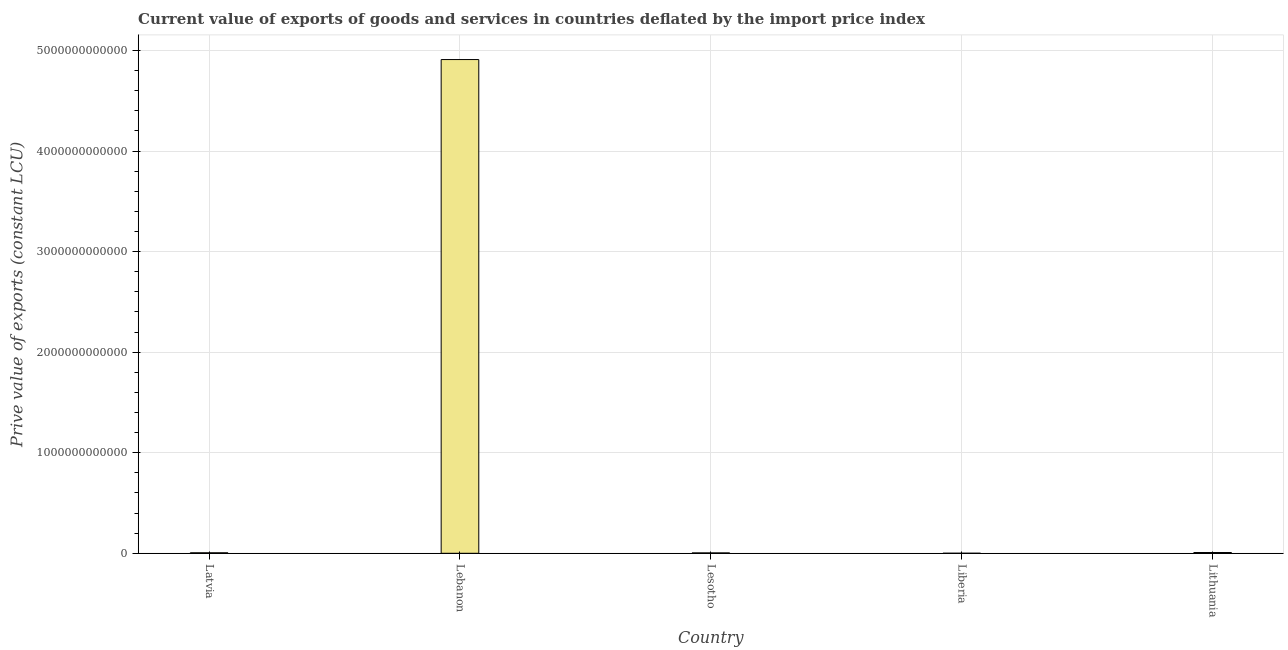Does the graph contain any zero values?
Your answer should be compact. No. What is the title of the graph?
Offer a very short reply. Current value of exports of goods and services in countries deflated by the import price index. What is the label or title of the X-axis?
Ensure brevity in your answer.  Country. What is the label or title of the Y-axis?
Ensure brevity in your answer.  Prive value of exports (constant LCU). What is the price value of exports in Latvia?
Ensure brevity in your answer.  4.90e+09. Across all countries, what is the maximum price value of exports?
Offer a very short reply. 4.91e+12. Across all countries, what is the minimum price value of exports?
Ensure brevity in your answer.  1.85e+08. In which country was the price value of exports maximum?
Your answer should be compact. Lebanon. In which country was the price value of exports minimum?
Your response must be concise. Liberia. What is the sum of the price value of exports?
Ensure brevity in your answer.  4.93e+12. What is the difference between the price value of exports in Lesotho and Lithuania?
Provide a short and direct response. -3.68e+09. What is the average price value of exports per country?
Offer a terse response. 9.85e+11. What is the median price value of exports?
Provide a succinct answer. 4.90e+09. What is the ratio of the price value of exports in Latvia to that in Lithuania?
Offer a terse response. 0.65. Is the price value of exports in Lebanon less than that in Lesotho?
Offer a terse response. No. What is the difference between the highest and the second highest price value of exports?
Provide a succinct answer. 4.90e+12. What is the difference between the highest and the lowest price value of exports?
Keep it short and to the point. 4.91e+12. Are all the bars in the graph horizontal?
Your answer should be compact. No. What is the difference between two consecutive major ticks on the Y-axis?
Provide a succinct answer. 1.00e+12. Are the values on the major ticks of Y-axis written in scientific E-notation?
Keep it short and to the point. No. What is the Prive value of exports (constant LCU) of Latvia?
Your answer should be very brief. 4.90e+09. What is the Prive value of exports (constant LCU) in Lebanon?
Give a very brief answer. 4.91e+12. What is the Prive value of exports (constant LCU) of Lesotho?
Keep it short and to the point. 3.86e+09. What is the Prive value of exports (constant LCU) in Liberia?
Make the answer very short. 1.85e+08. What is the Prive value of exports (constant LCU) in Lithuania?
Your response must be concise. 7.55e+09. What is the difference between the Prive value of exports (constant LCU) in Latvia and Lebanon?
Make the answer very short. -4.90e+12. What is the difference between the Prive value of exports (constant LCU) in Latvia and Lesotho?
Offer a terse response. 1.04e+09. What is the difference between the Prive value of exports (constant LCU) in Latvia and Liberia?
Offer a very short reply. 4.71e+09. What is the difference between the Prive value of exports (constant LCU) in Latvia and Lithuania?
Provide a short and direct response. -2.65e+09. What is the difference between the Prive value of exports (constant LCU) in Lebanon and Lesotho?
Provide a succinct answer. 4.91e+12. What is the difference between the Prive value of exports (constant LCU) in Lebanon and Liberia?
Your response must be concise. 4.91e+12. What is the difference between the Prive value of exports (constant LCU) in Lebanon and Lithuania?
Make the answer very short. 4.90e+12. What is the difference between the Prive value of exports (constant LCU) in Lesotho and Liberia?
Your answer should be very brief. 3.68e+09. What is the difference between the Prive value of exports (constant LCU) in Lesotho and Lithuania?
Provide a succinct answer. -3.68e+09. What is the difference between the Prive value of exports (constant LCU) in Liberia and Lithuania?
Give a very brief answer. -7.36e+09. What is the ratio of the Prive value of exports (constant LCU) in Latvia to that in Lesotho?
Your response must be concise. 1.27. What is the ratio of the Prive value of exports (constant LCU) in Latvia to that in Liberia?
Keep it short and to the point. 26.48. What is the ratio of the Prive value of exports (constant LCU) in Latvia to that in Lithuania?
Your response must be concise. 0.65. What is the ratio of the Prive value of exports (constant LCU) in Lebanon to that in Lesotho?
Your answer should be very brief. 1270.82. What is the ratio of the Prive value of exports (constant LCU) in Lebanon to that in Liberia?
Your answer should be compact. 2.65e+04. What is the ratio of the Prive value of exports (constant LCU) in Lebanon to that in Lithuania?
Your answer should be very brief. 650.54. What is the ratio of the Prive value of exports (constant LCU) in Lesotho to that in Liberia?
Your answer should be compact. 20.89. What is the ratio of the Prive value of exports (constant LCU) in Lesotho to that in Lithuania?
Provide a short and direct response. 0.51. What is the ratio of the Prive value of exports (constant LCU) in Liberia to that in Lithuania?
Offer a very short reply. 0.03. 